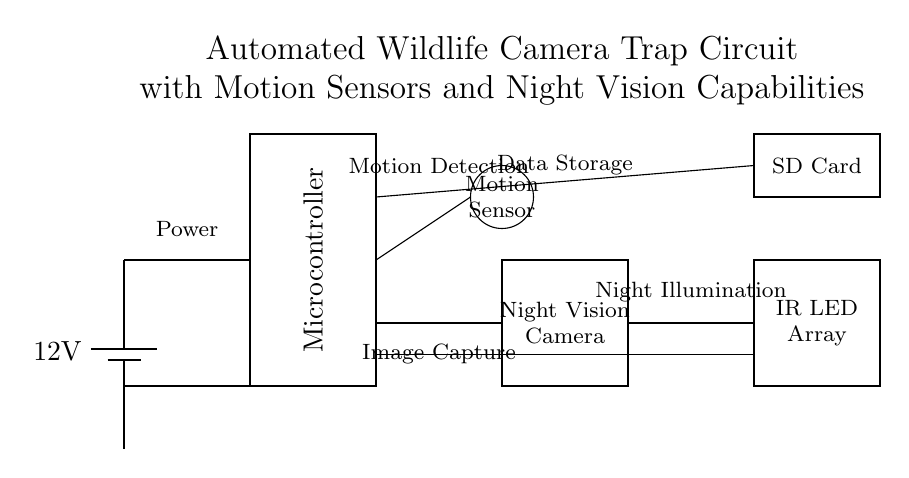What is the voltage of this circuit? The voltage is 12 volts, which is indicated by the battery component at the top left of the diagram. The battery is labeled with "12V," representing the potential difference it provides to the circuit.
Answer: 12 volts What components are used for night illumination? The components responsible for night illumination in this circuit are the IR LED Array, seen at the bottom right of the diagram, which is specifically designed to emit infrared light to aid visibility in low-light conditions.
Answer: IR LED Array How many primary components are in this circuit? There are four primary components in the circuit: the Microcontroller, Motion Sensor, Night Vision Camera, and IR LED Array. The circuit diagram shows these components as distinct parts, each serving a different function.
Answer: Four What is the purpose of the SD Card module? The SD Card module is used for data storage, allowing the captured images and other data to be saved for later retrieval. It is labeled clearly in the circuit diagram near the top right, indicating its function within the setup.
Answer: Data storage Which component initiates motion detection? The component that initiates motion detection is the Motion Sensor, located at the top right of the circuit. It interfaces with the Microcontroller to trigger the image capture process when motion is detected.
Answer: Motion Sensor How does the microcontroller interact with the motion sensor? The microcontroller interacts with the motion sensor through a connection that facilitates communication; when the motion sensor detects movement, it sends a signal to the microcontroller, which then activates the camera. This relationship allows for the automated function of the device.
Answer: Communication What function does the battery serve in the circuit? The battery serves as the power supply for the entire circuit, providing the necessary voltage to all components, ensuring they operate correctly. This is visually represented at the top left, where the battery connects to the other parts of the circuit.
Answer: Power supply 